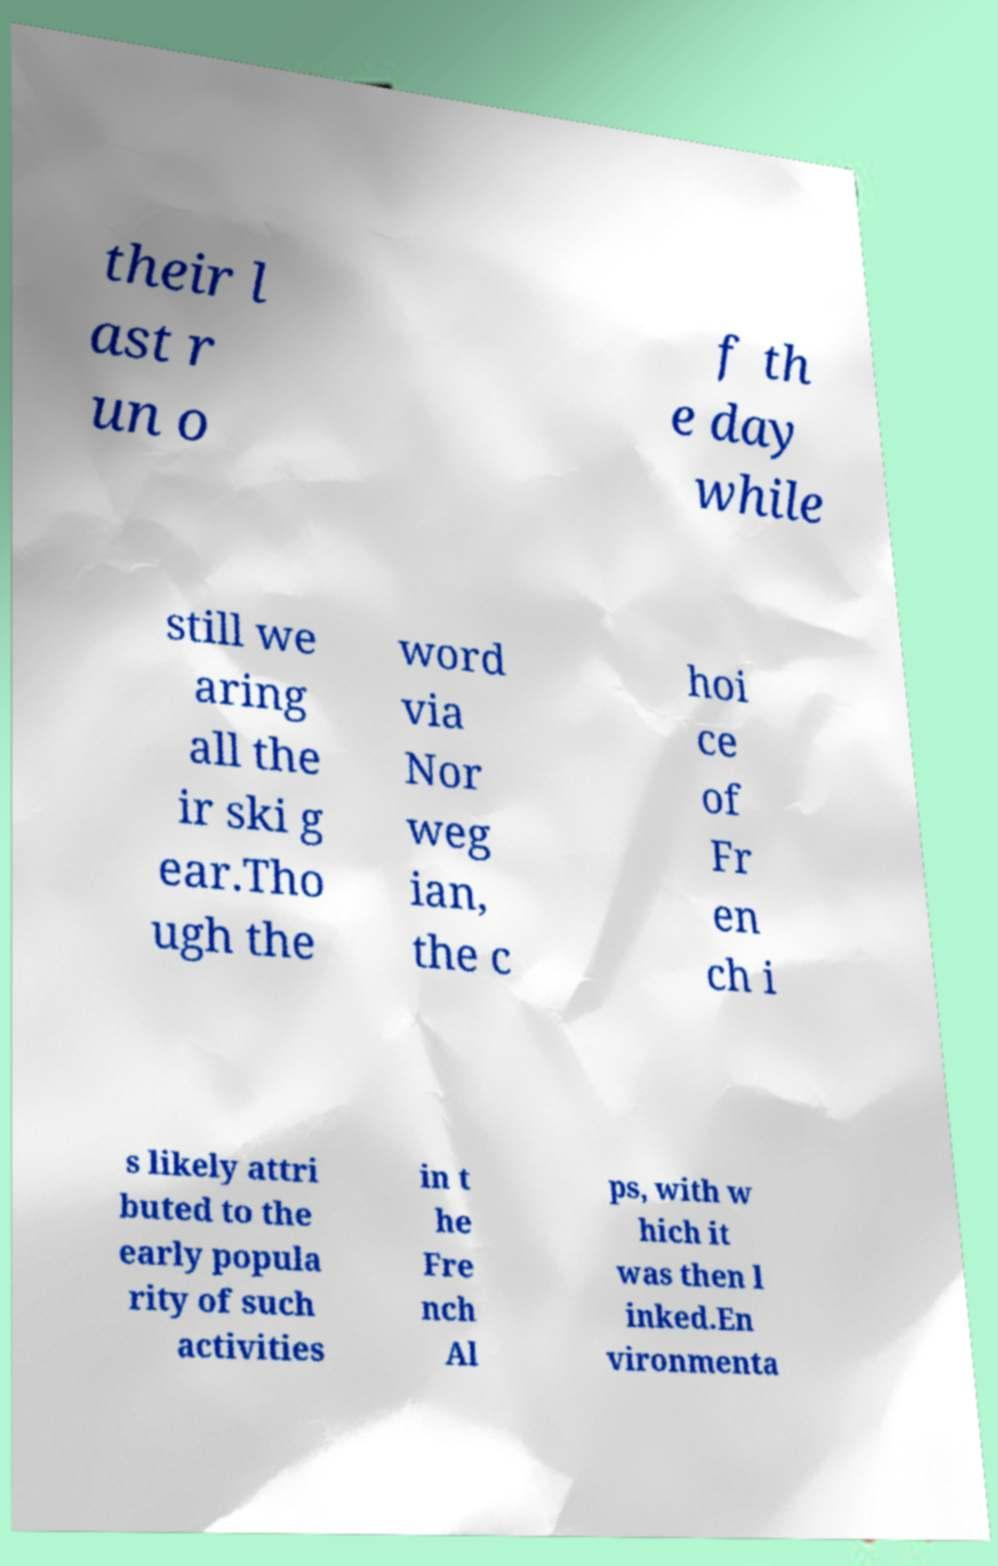Could you extract and type out the text from this image? their l ast r un o f th e day while still we aring all the ir ski g ear.Tho ugh the word via Nor weg ian, the c hoi ce of Fr en ch i s likely attri buted to the early popula rity of such activities in t he Fre nch Al ps, with w hich it was then l inked.En vironmenta 